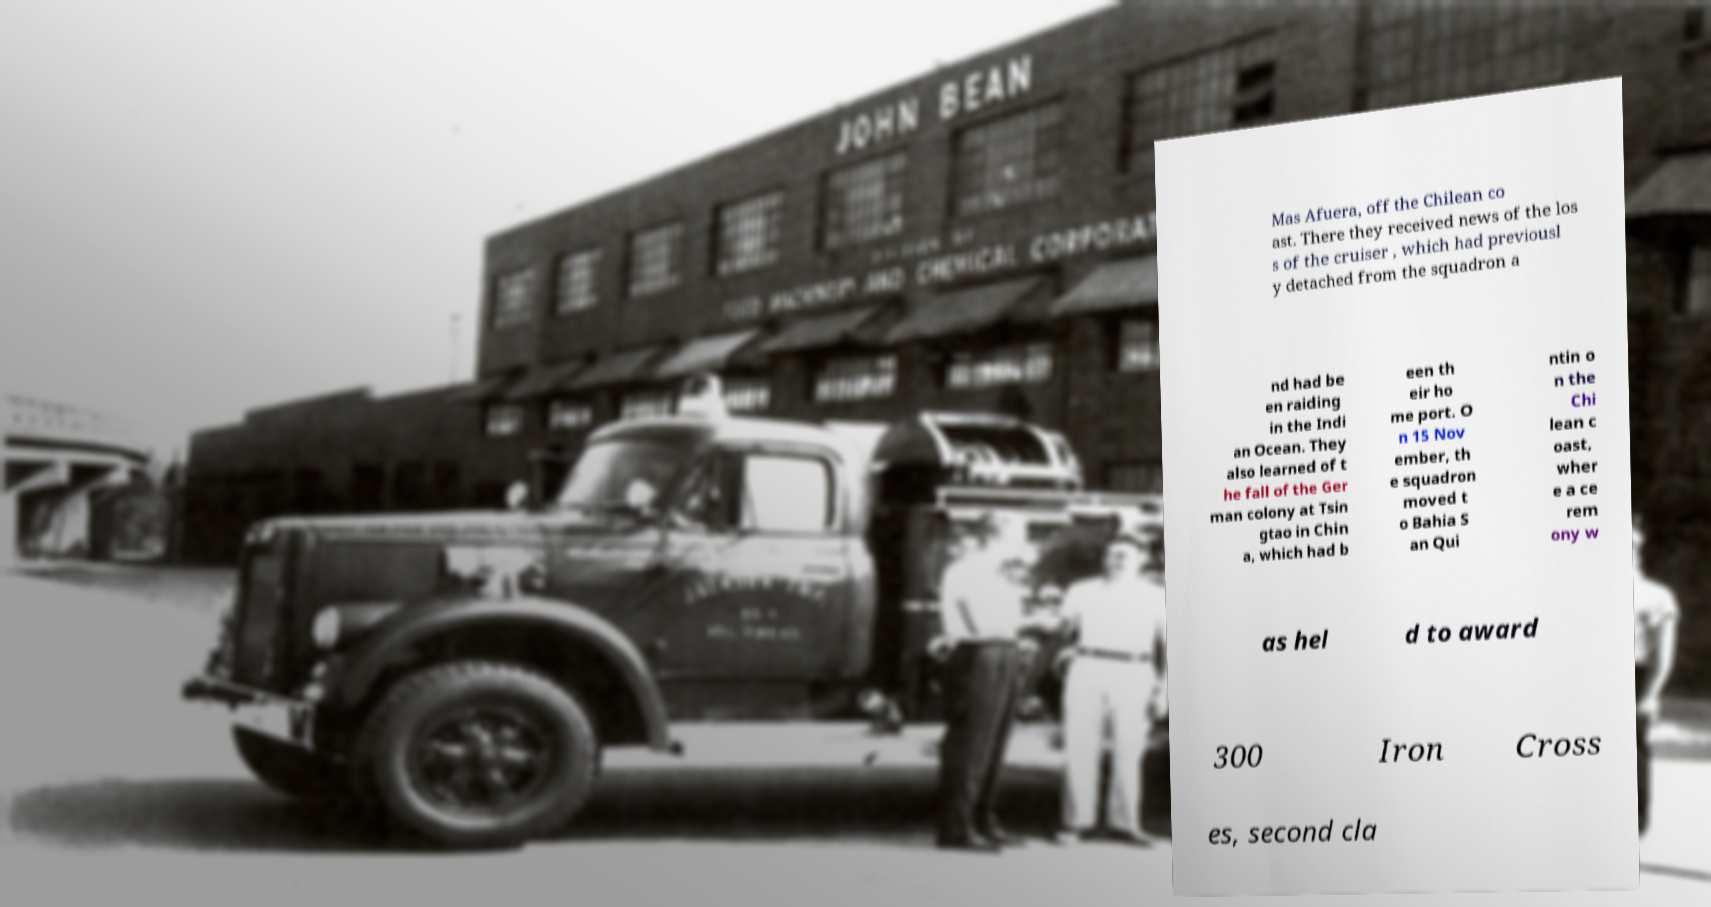Could you assist in decoding the text presented in this image and type it out clearly? Mas Afuera, off the Chilean co ast. There they received news of the los s of the cruiser , which had previousl y detached from the squadron a nd had be en raiding in the Indi an Ocean. They also learned of t he fall of the Ger man colony at Tsin gtao in Chin a, which had b een th eir ho me port. O n 15 Nov ember, th e squadron moved t o Bahia S an Qui ntin o n the Chi lean c oast, wher e a ce rem ony w as hel d to award 300 Iron Cross es, second cla 